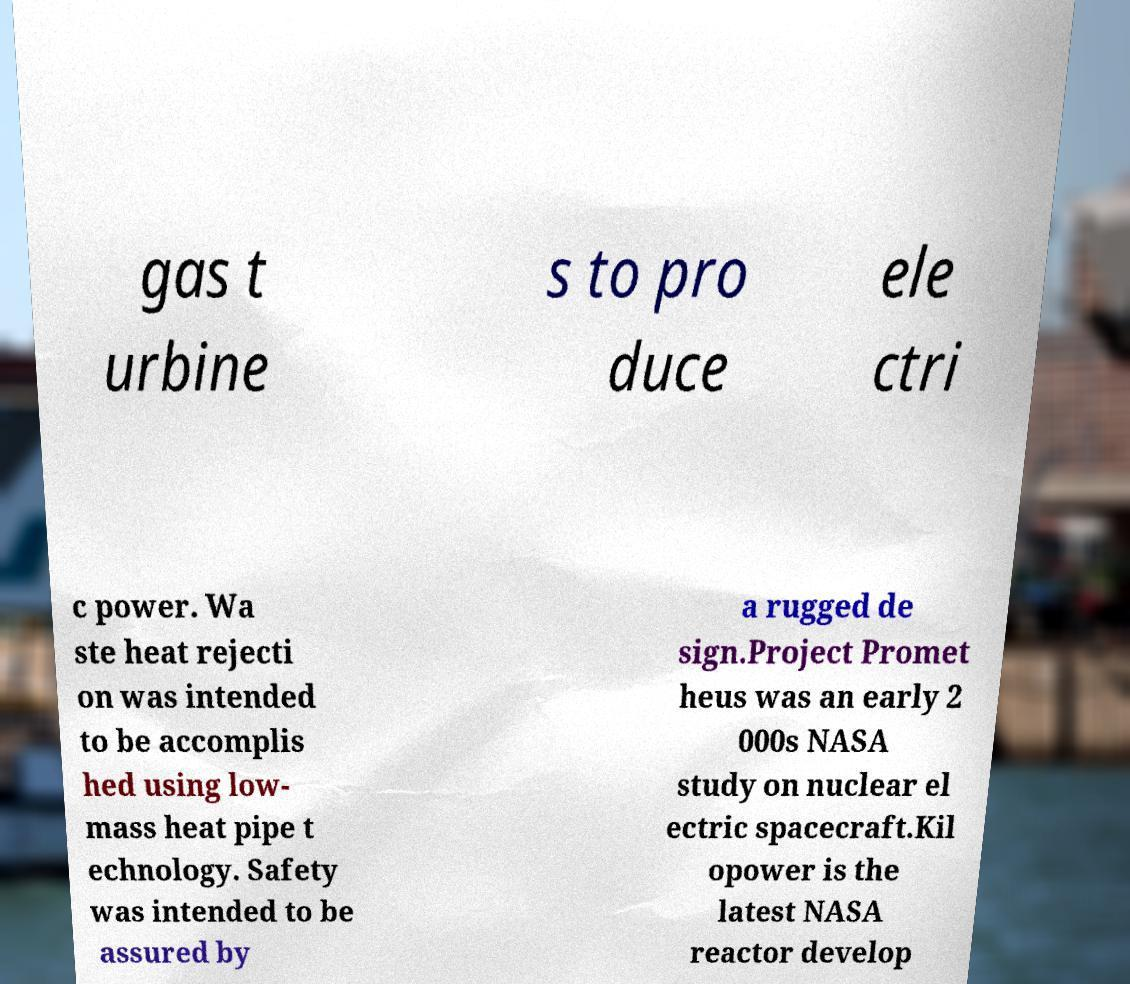There's text embedded in this image that I need extracted. Can you transcribe it verbatim? gas t urbine s to pro duce ele ctri c power. Wa ste heat rejecti on was intended to be accomplis hed using low- mass heat pipe t echnology. Safety was intended to be assured by a rugged de sign.Project Promet heus was an early 2 000s NASA study on nuclear el ectric spacecraft.Kil opower is the latest NASA reactor develop 